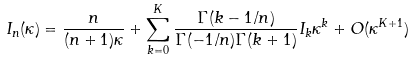Convert formula to latex. <formula><loc_0><loc_0><loc_500><loc_500>I _ { n } ( \kappa ) = \frac { n } { ( n + 1 ) \kappa } + \sum _ { k = 0 } ^ { K } \frac { \Gamma ( k - 1 / n ) } { \Gamma ( - 1 / n ) \Gamma ( k + 1 ) } I _ { k } \kappa ^ { k } + O ( \kappa ^ { K + 1 } )</formula> 